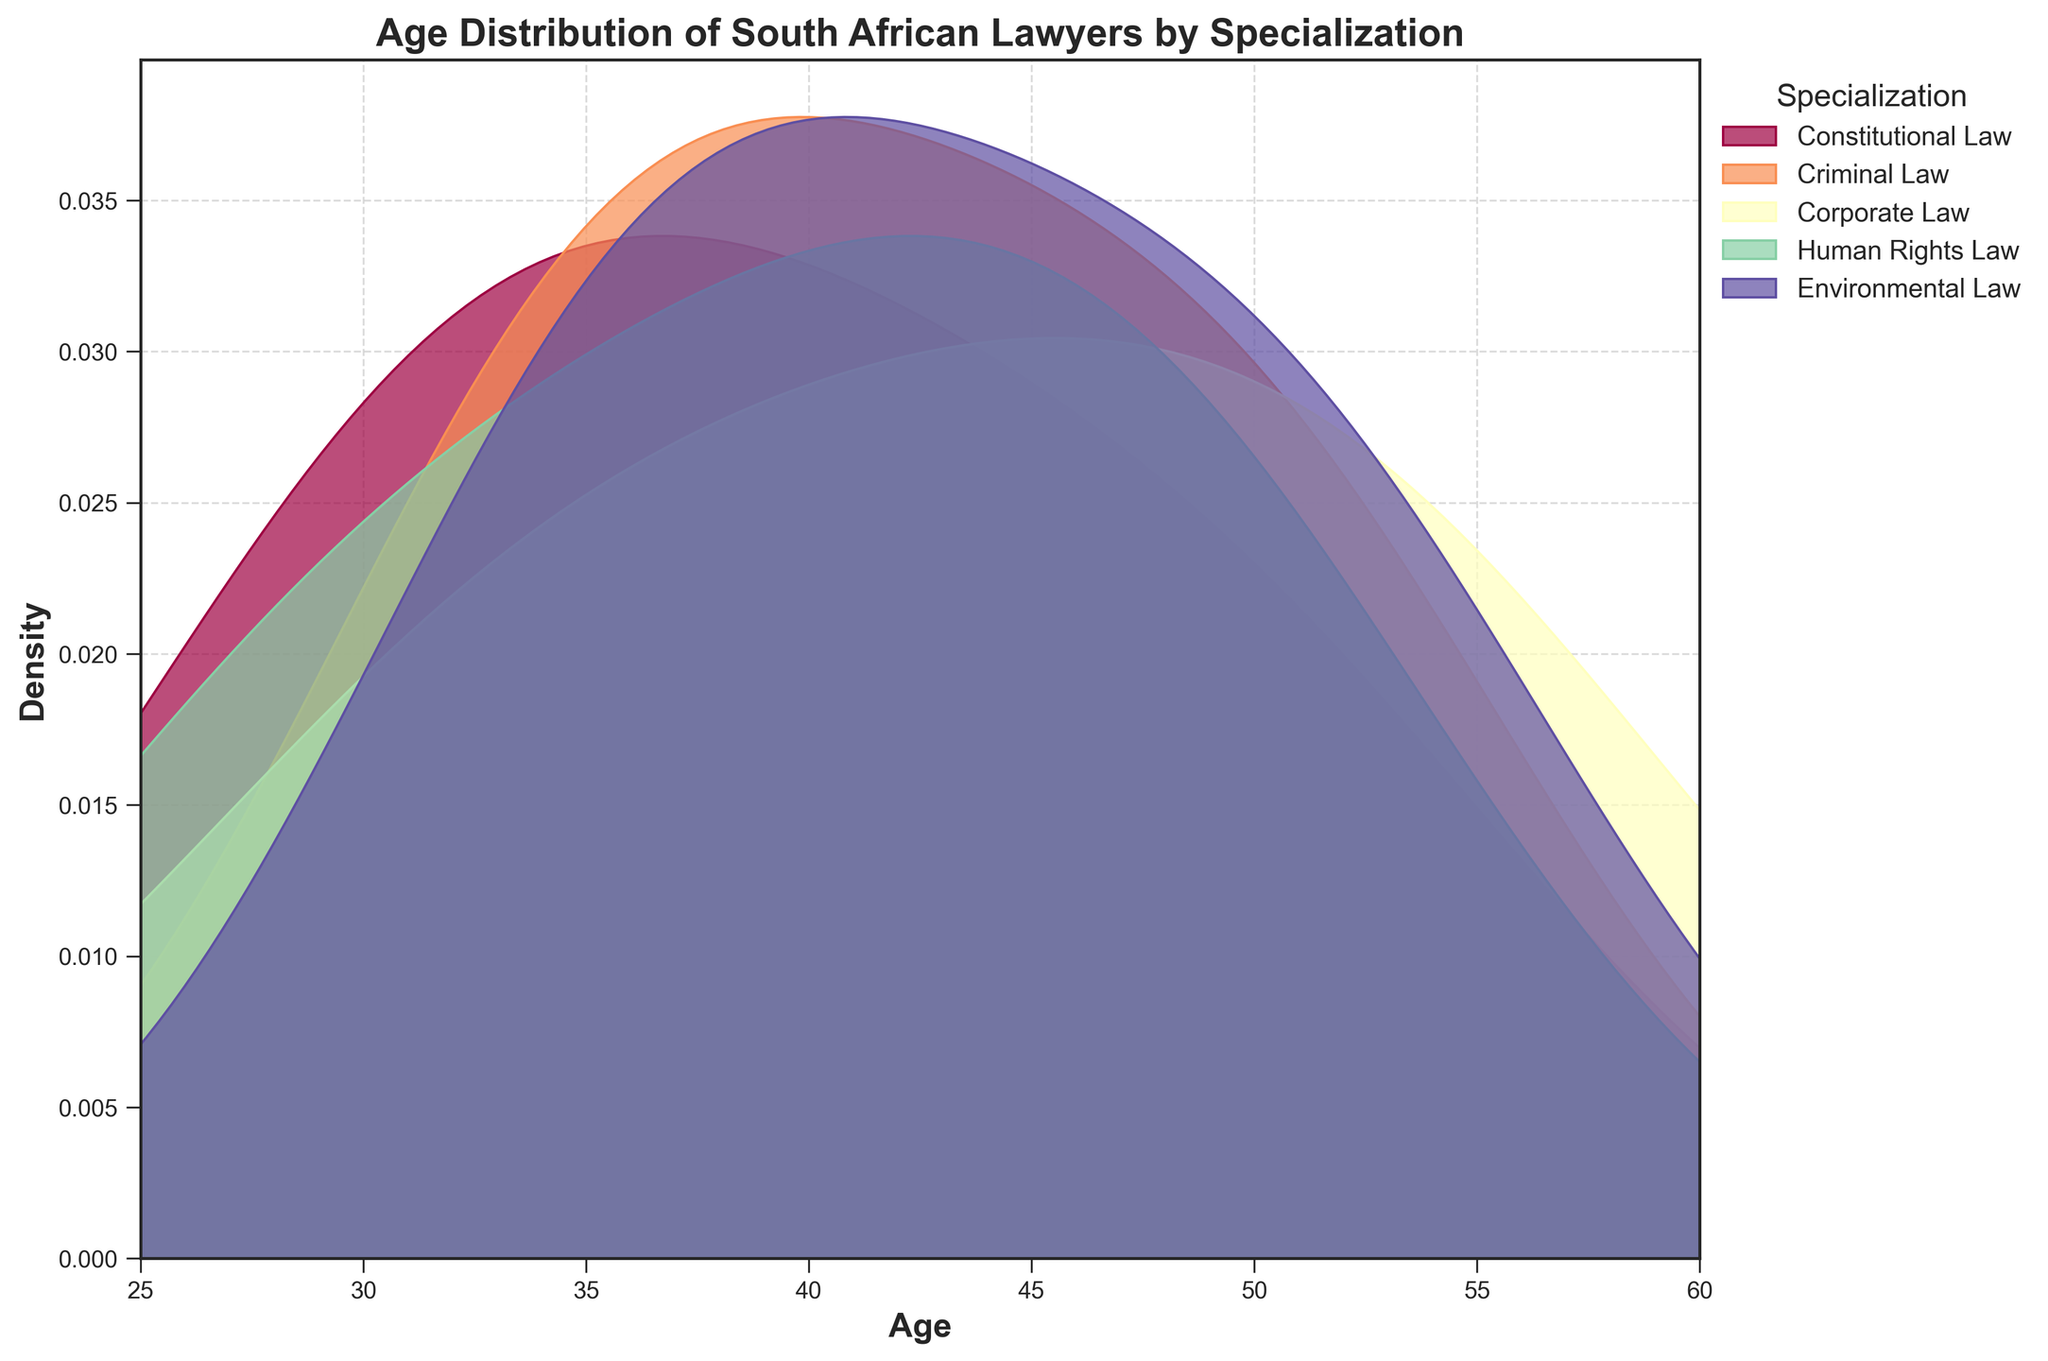What is the title of the plot? The title is present at the top of the plot, displaying the subject of the visual representation.
Answer: Age Distribution of South African Lawyers by Specialization Which specialization is the youngest lawyer most likely affiliated with? By looking at the leftmost peaks in the density plot, Constitutional Law and Human Rights Law are associated with the youngest lawyers. The leftmost density peak for Human Rights Law is approximately at age 28, which is slightly younger than the leftmost peak for Constitutional Law at 29.
Answer: Human Rights Law What is the age range covered on the x-axis? The x-axis, which indicates age, starts at 25 and ends at 60. This can be inferred from the axis labels and tick marks.
Answer: 25 to 60 Which specialization has the most widespread age distribution? By observing the spread or width of the density plots, Criminal Law and Corporate Law have relatively broader spreads, indicating a wider age distribution compared to other specializations.
Answer: Criminal Law and Corporate Law Which specialization has the highest density peak for age? The height of the peaks in the density plot represents the density. By comparing the height of the curves, Human Rights Law has a noticeably higher peak approximately at age 50.
Answer: Human Rights Law What can you infer about the age distribution of Environmental Law specialists? The density plot for Environmental Law shows a significant density around mid-to-late 40s and early 50s, indicating that Environmental Law specialists are generally older compared to those in other specializations.
Answer: Generally older, mid-to-late 40s and early 50s Comparing Criminal Law and Corporate Law, which specialization has older practitioners? By comparing the density plots of Criminal Law and Corporate Law, one can see that the density for older age groups (past 50) is slightly higher for Corporate Law.
Answer: Corporate Law Do any specializations overlap in their age distributions? By observing the plots, one can see that the age distributions for different specializations overlap to some extent. For example, Constitutional Law, Criminal Law, and Corporate Law all overlap around the age 40 to 50 range.
Answer: Yes, multiple overlaps From the density plots, which specialization seems to have the least variability in age? The specialization with the most concentrated peak and least spread is Human Rights Law, implying less variability in age among its practitioners.
Answer: Human Rights Law 